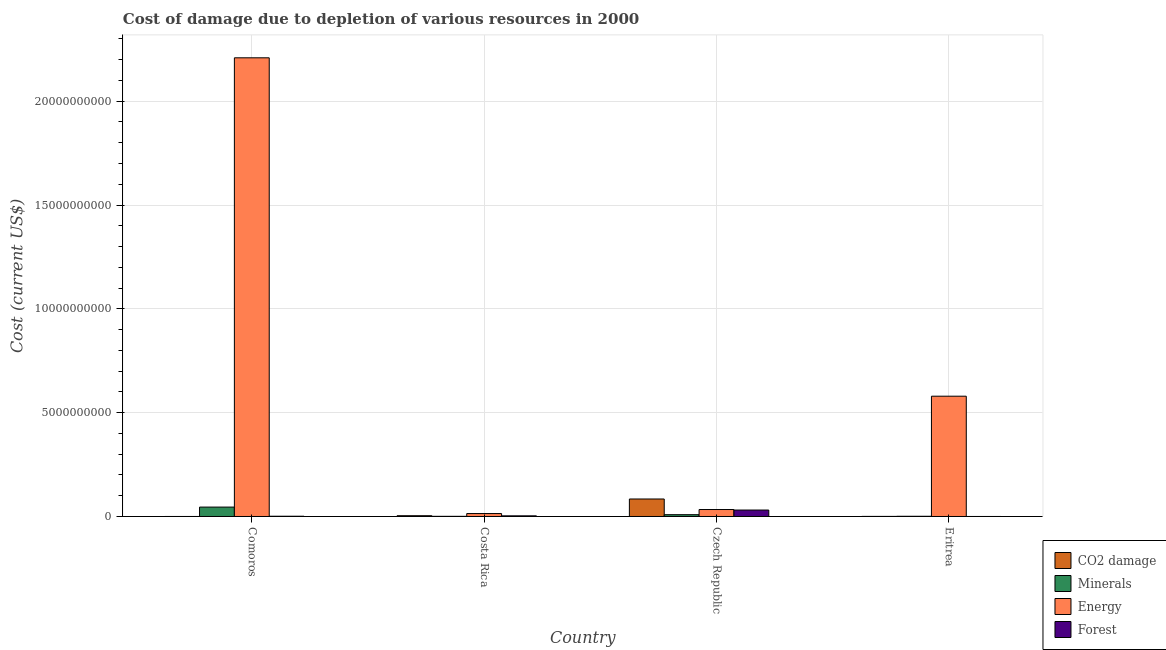Are the number of bars on each tick of the X-axis equal?
Your answer should be very brief. Yes. How many bars are there on the 3rd tick from the left?
Offer a very short reply. 4. What is the label of the 1st group of bars from the left?
Keep it short and to the point. Comoros. What is the cost of damage due to depletion of coal in Czech Republic?
Ensure brevity in your answer.  8.42e+08. Across all countries, what is the maximum cost of damage due to depletion of minerals?
Offer a very short reply. 4.53e+08. Across all countries, what is the minimum cost of damage due to depletion of energy?
Give a very brief answer. 1.41e+08. In which country was the cost of damage due to depletion of energy maximum?
Keep it short and to the point. Comoros. In which country was the cost of damage due to depletion of coal minimum?
Offer a very short reply. Comoros. What is the total cost of damage due to depletion of forests in the graph?
Ensure brevity in your answer.  3.54e+08. What is the difference between the cost of damage due to depletion of forests in Comoros and that in Czech Republic?
Make the answer very short. -2.98e+08. What is the difference between the cost of damage due to depletion of energy in Comoros and the cost of damage due to depletion of coal in Eritrea?
Give a very brief answer. 2.21e+1. What is the average cost of damage due to depletion of coal per country?
Give a very brief answer. 2.21e+08. What is the difference between the cost of damage due to depletion of energy and cost of damage due to depletion of forests in Czech Republic?
Offer a very short reply. 2.53e+07. What is the ratio of the cost of damage due to depletion of forests in Costa Rica to that in Eritrea?
Your answer should be compact. 665.52. Is the cost of damage due to depletion of energy in Costa Rica less than that in Czech Republic?
Provide a succinct answer. Yes. What is the difference between the highest and the second highest cost of damage due to depletion of minerals?
Give a very brief answer. 3.66e+08. What is the difference between the highest and the lowest cost of damage due to depletion of forests?
Keep it short and to the point. 3.10e+08. In how many countries, is the cost of damage due to depletion of minerals greater than the average cost of damage due to depletion of minerals taken over all countries?
Offer a terse response. 1. Is the sum of the cost of damage due to depletion of energy in Comoros and Czech Republic greater than the maximum cost of damage due to depletion of coal across all countries?
Make the answer very short. Yes. What does the 2nd bar from the left in Czech Republic represents?
Ensure brevity in your answer.  Minerals. What does the 3rd bar from the right in Czech Republic represents?
Ensure brevity in your answer.  Minerals. Is it the case that in every country, the sum of the cost of damage due to depletion of coal and cost of damage due to depletion of minerals is greater than the cost of damage due to depletion of energy?
Provide a succinct answer. No. What is the difference between two consecutive major ticks on the Y-axis?
Your answer should be very brief. 5.00e+09. Are the values on the major ticks of Y-axis written in scientific E-notation?
Provide a short and direct response. No. Where does the legend appear in the graph?
Give a very brief answer. Bottom right. How many legend labels are there?
Your response must be concise. 4. What is the title of the graph?
Make the answer very short. Cost of damage due to depletion of various resources in 2000 . Does "Rule based governance" appear as one of the legend labels in the graph?
Your response must be concise. No. What is the label or title of the Y-axis?
Ensure brevity in your answer.  Cost (current US$). What is the Cost (current US$) of CO2 damage in Comoros?
Offer a very short reply. 5.74e+05. What is the Cost (current US$) of Minerals in Comoros?
Ensure brevity in your answer.  4.53e+08. What is the Cost (current US$) in Energy in Comoros?
Offer a very short reply. 2.21e+1. What is the Cost (current US$) in Forest in Comoros?
Keep it short and to the point. 1.21e+07. What is the Cost (current US$) in CO2 damage in Costa Rica?
Offer a terse response. 3.73e+07. What is the Cost (current US$) of Minerals in Costa Rica?
Your answer should be compact. 7.79e+06. What is the Cost (current US$) in Energy in Costa Rica?
Ensure brevity in your answer.  1.41e+08. What is the Cost (current US$) of Forest in Costa Rica?
Provide a short and direct response. 3.11e+07. What is the Cost (current US$) in CO2 damage in Czech Republic?
Give a very brief answer. 8.42e+08. What is the Cost (current US$) in Minerals in Czech Republic?
Offer a very short reply. 8.69e+07. What is the Cost (current US$) of Energy in Czech Republic?
Ensure brevity in your answer.  3.36e+08. What is the Cost (current US$) in Forest in Czech Republic?
Make the answer very short. 3.10e+08. What is the Cost (current US$) in CO2 damage in Eritrea?
Your answer should be compact. 4.15e+06. What is the Cost (current US$) in Minerals in Eritrea?
Give a very brief answer. 1.04e+07. What is the Cost (current US$) of Energy in Eritrea?
Ensure brevity in your answer.  5.79e+09. What is the Cost (current US$) of Forest in Eritrea?
Give a very brief answer. 4.68e+04. Across all countries, what is the maximum Cost (current US$) of CO2 damage?
Ensure brevity in your answer.  8.42e+08. Across all countries, what is the maximum Cost (current US$) in Minerals?
Make the answer very short. 4.53e+08. Across all countries, what is the maximum Cost (current US$) in Energy?
Provide a short and direct response. 2.21e+1. Across all countries, what is the maximum Cost (current US$) in Forest?
Offer a terse response. 3.10e+08. Across all countries, what is the minimum Cost (current US$) of CO2 damage?
Provide a short and direct response. 5.74e+05. Across all countries, what is the minimum Cost (current US$) in Minerals?
Your response must be concise. 7.79e+06. Across all countries, what is the minimum Cost (current US$) in Energy?
Keep it short and to the point. 1.41e+08. Across all countries, what is the minimum Cost (current US$) in Forest?
Offer a terse response. 4.68e+04. What is the total Cost (current US$) in CO2 damage in the graph?
Make the answer very short. 8.84e+08. What is the total Cost (current US$) in Minerals in the graph?
Make the answer very short. 5.58e+08. What is the total Cost (current US$) in Energy in the graph?
Keep it short and to the point. 2.84e+1. What is the total Cost (current US$) of Forest in the graph?
Ensure brevity in your answer.  3.54e+08. What is the difference between the Cost (current US$) in CO2 damage in Comoros and that in Costa Rica?
Provide a succinct answer. -3.67e+07. What is the difference between the Cost (current US$) in Minerals in Comoros and that in Costa Rica?
Your answer should be compact. 4.45e+08. What is the difference between the Cost (current US$) of Energy in Comoros and that in Costa Rica?
Make the answer very short. 2.19e+1. What is the difference between the Cost (current US$) of Forest in Comoros and that in Costa Rica?
Offer a terse response. -1.90e+07. What is the difference between the Cost (current US$) in CO2 damage in Comoros and that in Czech Republic?
Keep it short and to the point. -8.42e+08. What is the difference between the Cost (current US$) of Minerals in Comoros and that in Czech Republic?
Offer a terse response. 3.66e+08. What is the difference between the Cost (current US$) in Energy in Comoros and that in Czech Republic?
Provide a succinct answer. 2.18e+1. What is the difference between the Cost (current US$) of Forest in Comoros and that in Czech Republic?
Your answer should be very brief. -2.98e+08. What is the difference between the Cost (current US$) of CO2 damage in Comoros and that in Eritrea?
Ensure brevity in your answer.  -3.57e+06. What is the difference between the Cost (current US$) of Minerals in Comoros and that in Eritrea?
Ensure brevity in your answer.  4.42e+08. What is the difference between the Cost (current US$) in Energy in Comoros and that in Eritrea?
Give a very brief answer. 1.63e+1. What is the difference between the Cost (current US$) in Forest in Comoros and that in Eritrea?
Make the answer very short. 1.21e+07. What is the difference between the Cost (current US$) of CO2 damage in Costa Rica and that in Czech Republic?
Offer a very short reply. -8.05e+08. What is the difference between the Cost (current US$) in Minerals in Costa Rica and that in Czech Republic?
Make the answer very short. -7.91e+07. What is the difference between the Cost (current US$) in Energy in Costa Rica and that in Czech Republic?
Offer a very short reply. -1.95e+08. What is the difference between the Cost (current US$) of Forest in Costa Rica and that in Czech Republic?
Offer a very short reply. -2.79e+08. What is the difference between the Cost (current US$) of CO2 damage in Costa Rica and that in Eritrea?
Offer a terse response. 3.31e+07. What is the difference between the Cost (current US$) in Minerals in Costa Rica and that in Eritrea?
Give a very brief answer. -2.63e+06. What is the difference between the Cost (current US$) in Energy in Costa Rica and that in Eritrea?
Provide a short and direct response. -5.65e+09. What is the difference between the Cost (current US$) of Forest in Costa Rica and that in Eritrea?
Provide a short and direct response. 3.11e+07. What is the difference between the Cost (current US$) in CO2 damage in Czech Republic and that in Eritrea?
Offer a very short reply. 8.38e+08. What is the difference between the Cost (current US$) in Minerals in Czech Republic and that in Eritrea?
Offer a terse response. 7.64e+07. What is the difference between the Cost (current US$) in Energy in Czech Republic and that in Eritrea?
Make the answer very short. -5.46e+09. What is the difference between the Cost (current US$) in Forest in Czech Republic and that in Eritrea?
Offer a very short reply. 3.10e+08. What is the difference between the Cost (current US$) of CO2 damage in Comoros and the Cost (current US$) of Minerals in Costa Rica?
Offer a very short reply. -7.22e+06. What is the difference between the Cost (current US$) in CO2 damage in Comoros and the Cost (current US$) in Energy in Costa Rica?
Give a very brief answer. -1.40e+08. What is the difference between the Cost (current US$) of CO2 damage in Comoros and the Cost (current US$) of Forest in Costa Rica?
Provide a short and direct response. -3.05e+07. What is the difference between the Cost (current US$) of Minerals in Comoros and the Cost (current US$) of Energy in Costa Rica?
Provide a short and direct response. 3.12e+08. What is the difference between the Cost (current US$) of Minerals in Comoros and the Cost (current US$) of Forest in Costa Rica?
Offer a terse response. 4.22e+08. What is the difference between the Cost (current US$) of Energy in Comoros and the Cost (current US$) of Forest in Costa Rica?
Ensure brevity in your answer.  2.21e+1. What is the difference between the Cost (current US$) of CO2 damage in Comoros and the Cost (current US$) of Minerals in Czech Republic?
Your answer should be compact. -8.63e+07. What is the difference between the Cost (current US$) in CO2 damage in Comoros and the Cost (current US$) in Energy in Czech Republic?
Provide a short and direct response. -3.35e+08. What is the difference between the Cost (current US$) in CO2 damage in Comoros and the Cost (current US$) in Forest in Czech Republic?
Your response must be concise. -3.10e+08. What is the difference between the Cost (current US$) in Minerals in Comoros and the Cost (current US$) in Energy in Czech Republic?
Your answer should be very brief. 1.17e+08. What is the difference between the Cost (current US$) of Minerals in Comoros and the Cost (current US$) of Forest in Czech Republic?
Give a very brief answer. 1.42e+08. What is the difference between the Cost (current US$) of Energy in Comoros and the Cost (current US$) of Forest in Czech Republic?
Ensure brevity in your answer.  2.18e+1. What is the difference between the Cost (current US$) of CO2 damage in Comoros and the Cost (current US$) of Minerals in Eritrea?
Your response must be concise. -9.85e+06. What is the difference between the Cost (current US$) of CO2 damage in Comoros and the Cost (current US$) of Energy in Eritrea?
Provide a succinct answer. -5.79e+09. What is the difference between the Cost (current US$) in CO2 damage in Comoros and the Cost (current US$) in Forest in Eritrea?
Your answer should be very brief. 5.28e+05. What is the difference between the Cost (current US$) in Minerals in Comoros and the Cost (current US$) in Energy in Eritrea?
Provide a short and direct response. -5.34e+09. What is the difference between the Cost (current US$) in Minerals in Comoros and the Cost (current US$) in Forest in Eritrea?
Your answer should be very brief. 4.53e+08. What is the difference between the Cost (current US$) in Energy in Comoros and the Cost (current US$) in Forest in Eritrea?
Provide a succinct answer. 2.21e+1. What is the difference between the Cost (current US$) in CO2 damage in Costa Rica and the Cost (current US$) in Minerals in Czech Republic?
Offer a terse response. -4.96e+07. What is the difference between the Cost (current US$) of CO2 damage in Costa Rica and the Cost (current US$) of Energy in Czech Republic?
Your answer should be very brief. -2.98e+08. What is the difference between the Cost (current US$) in CO2 damage in Costa Rica and the Cost (current US$) in Forest in Czech Republic?
Make the answer very short. -2.73e+08. What is the difference between the Cost (current US$) of Minerals in Costa Rica and the Cost (current US$) of Energy in Czech Republic?
Keep it short and to the point. -3.28e+08. What is the difference between the Cost (current US$) in Minerals in Costa Rica and the Cost (current US$) in Forest in Czech Republic?
Give a very brief answer. -3.03e+08. What is the difference between the Cost (current US$) in Energy in Costa Rica and the Cost (current US$) in Forest in Czech Republic?
Your answer should be very brief. -1.70e+08. What is the difference between the Cost (current US$) of CO2 damage in Costa Rica and the Cost (current US$) of Minerals in Eritrea?
Offer a terse response. 2.69e+07. What is the difference between the Cost (current US$) of CO2 damage in Costa Rica and the Cost (current US$) of Energy in Eritrea?
Your answer should be very brief. -5.76e+09. What is the difference between the Cost (current US$) in CO2 damage in Costa Rica and the Cost (current US$) in Forest in Eritrea?
Keep it short and to the point. 3.72e+07. What is the difference between the Cost (current US$) of Minerals in Costa Rica and the Cost (current US$) of Energy in Eritrea?
Your response must be concise. -5.79e+09. What is the difference between the Cost (current US$) of Minerals in Costa Rica and the Cost (current US$) of Forest in Eritrea?
Provide a succinct answer. 7.75e+06. What is the difference between the Cost (current US$) of Energy in Costa Rica and the Cost (current US$) of Forest in Eritrea?
Offer a very short reply. 1.41e+08. What is the difference between the Cost (current US$) of CO2 damage in Czech Republic and the Cost (current US$) of Minerals in Eritrea?
Offer a terse response. 8.32e+08. What is the difference between the Cost (current US$) of CO2 damage in Czech Republic and the Cost (current US$) of Energy in Eritrea?
Ensure brevity in your answer.  -4.95e+09. What is the difference between the Cost (current US$) in CO2 damage in Czech Republic and the Cost (current US$) in Forest in Eritrea?
Provide a short and direct response. 8.42e+08. What is the difference between the Cost (current US$) in Minerals in Czech Republic and the Cost (current US$) in Energy in Eritrea?
Give a very brief answer. -5.71e+09. What is the difference between the Cost (current US$) of Minerals in Czech Republic and the Cost (current US$) of Forest in Eritrea?
Make the answer very short. 8.68e+07. What is the difference between the Cost (current US$) of Energy in Czech Republic and the Cost (current US$) of Forest in Eritrea?
Offer a very short reply. 3.36e+08. What is the average Cost (current US$) of CO2 damage per country?
Give a very brief answer. 2.21e+08. What is the average Cost (current US$) in Minerals per country?
Your answer should be very brief. 1.39e+08. What is the average Cost (current US$) in Energy per country?
Your answer should be compact. 7.09e+09. What is the average Cost (current US$) of Forest per country?
Give a very brief answer. 8.84e+07. What is the difference between the Cost (current US$) of CO2 damage and Cost (current US$) of Minerals in Comoros?
Ensure brevity in your answer.  -4.52e+08. What is the difference between the Cost (current US$) in CO2 damage and Cost (current US$) in Energy in Comoros?
Your answer should be compact. -2.21e+1. What is the difference between the Cost (current US$) in CO2 damage and Cost (current US$) in Forest in Comoros?
Provide a succinct answer. -1.16e+07. What is the difference between the Cost (current US$) in Minerals and Cost (current US$) in Energy in Comoros?
Your answer should be compact. -2.16e+1. What is the difference between the Cost (current US$) of Minerals and Cost (current US$) of Forest in Comoros?
Your answer should be compact. 4.41e+08. What is the difference between the Cost (current US$) of Energy and Cost (current US$) of Forest in Comoros?
Your answer should be compact. 2.21e+1. What is the difference between the Cost (current US$) in CO2 damage and Cost (current US$) in Minerals in Costa Rica?
Ensure brevity in your answer.  2.95e+07. What is the difference between the Cost (current US$) in CO2 damage and Cost (current US$) in Energy in Costa Rica?
Ensure brevity in your answer.  -1.04e+08. What is the difference between the Cost (current US$) of CO2 damage and Cost (current US$) of Forest in Costa Rica?
Keep it short and to the point. 6.17e+06. What is the difference between the Cost (current US$) in Minerals and Cost (current US$) in Energy in Costa Rica?
Make the answer very short. -1.33e+08. What is the difference between the Cost (current US$) in Minerals and Cost (current US$) in Forest in Costa Rica?
Give a very brief answer. -2.33e+07. What is the difference between the Cost (current US$) of Energy and Cost (current US$) of Forest in Costa Rica?
Provide a short and direct response. 1.10e+08. What is the difference between the Cost (current US$) in CO2 damage and Cost (current US$) in Minerals in Czech Republic?
Your response must be concise. 7.56e+08. What is the difference between the Cost (current US$) in CO2 damage and Cost (current US$) in Energy in Czech Republic?
Your answer should be compact. 5.07e+08. What is the difference between the Cost (current US$) of CO2 damage and Cost (current US$) of Forest in Czech Republic?
Offer a terse response. 5.32e+08. What is the difference between the Cost (current US$) in Minerals and Cost (current US$) in Energy in Czech Republic?
Your answer should be very brief. -2.49e+08. What is the difference between the Cost (current US$) of Minerals and Cost (current US$) of Forest in Czech Republic?
Your response must be concise. -2.24e+08. What is the difference between the Cost (current US$) of Energy and Cost (current US$) of Forest in Czech Republic?
Provide a succinct answer. 2.53e+07. What is the difference between the Cost (current US$) of CO2 damage and Cost (current US$) of Minerals in Eritrea?
Your answer should be compact. -6.28e+06. What is the difference between the Cost (current US$) in CO2 damage and Cost (current US$) in Energy in Eritrea?
Ensure brevity in your answer.  -5.79e+09. What is the difference between the Cost (current US$) of CO2 damage and Cost (current US$) of Forest in Eritrea?
Make the answer very short. 4.10e+06. What is the difference between the Cost (current US$) in Minerals and Cost (current US$) in Energy in Eritrea?
Offer a very short reply. -5.78e+09. What is the difference between the Cost (current US$) of Minerals and Cost (current US$) of Forest in Eritrea?
Make the answer very short. 1.04e+07. What is the difference between the Cost (current US$) in Energy and Cost (current US$) in Forest in Eritrea?
Provide a short and direct response. 5.79e+09. What is the ratio of the Cost (current US$) in CO2 damage in Comoros to that in Costa Rica?
Offer a terse response. 0.02. What is the ratio of the Cost (current US$) of Minerals in Comoros to that in Costa Rica?
Give a very brief answer. 58.09. What is the ratio of the Cost (current US$) of Energy in Comoros to that in Costa Rica?
Keep it short and to the point. 156.89. What is the ratio of the Cost (current US$) of Forest in Comoros to that in Costa Rica?
Offer a very short reply. 0.39. What is the ratio of the Cost (current US$) in CO2 damage in Comoros to that in Czech Republic?
Offer a terse response. 0. What is the ratio of the Cost (current US$) in Minerals in Comoros to that in Czech Republic?
Your response must be concise. 5.21. What is the ratio of the Cost (current US$) of Energy in Comoros to that in Czech Republic?
Provide a short and direct response. 65.81. What is the ratio of the Cost (current US$) of Forest in Comoros to that in Czech Republic?
Your answer should be compact. 0.04. What is the ratio of the Cost (current US$) in CO2 damage in Comoros to that in Eritrea?
Provide a short and direct response. 0.14. What is the ratio of the Cost (current US$) of Minerals in Comoros to that in Eritrea?
Your answer should be compact. 43.42. What is the ratio of the Cost (current US$) in Energy in Comoros to that in Eritrea?
Give a very brief answer. 3.81. What is the ratio of the Cost (current US$) in Forest in Comoros to that in Eritrea?
Offer a very short reply. 259.7. What is the ratio of the Cost (current US$) of CO2 damage in Costa Rica to that in Czech Republic?
Your response must be concise. 0.04. What is the ratio of the Cost (current US$) in Minerals in Costa Rica to that in Czech Republic?
Provide a succinct answer. 0.09. What is the ratio of the Cost (current US$) in Energy in Costa Rica to that in Czech Republic?
Offer a very short reply. 0.42. What is the ratio of the Cost (current US$) of Forest in Costa Rica to that in Czech Republic?
Your answer should be compact. 0.1. What is the ratio of the Cost (current US$) of CO2 damage in Costa Rica to that in Eritrea?
Offer a very short reply. 8.99. What is the ratio of the Cost (current US$) of Minerals in Costa Rica to that in Eritrea?
Offer a very short reply. 0.75. What is the ratio of the Cost (current US$) in Energy in Costa Rica to that in Eritrea?
Make the answer very short. 0.02. What is the ratio of the Cost (current US$) of Forest in Costa Rica to that in Eritrea?
Your answer should be very brief. 665.52. What is the ratio of the Cost (current US$) in CO2 damage in Czech Republic to that in Eritrea?
Give a very brief answer. 203.19. What is the ratio of the Cost (current US$) in Minerals in Czech Republic to that in Eritrea?
Make the answer very short. 8.33. What is the ratio of the Cost (current US$) in Energy in Czech Republic to that in Eritrea?
Your response must be concise. 0.06. What is the ratio of the Cost (current US$) in Forest in Czech Republic to that in Eritrea?
Offer a terse response. 6637.14. What is the difference between the highest and the second highest Cost (current US$) in CO2 damage?
Your answer should be compact. 8.05e+08. What is the difference between the highest and the second highest Cost (current US$) in Minerals?
Keep it short and to the point. 3.66e+08. What is the difference between the highest and the second highest Cost (current US$) of Energy?
Your answer should be compact. 1.63e+1. What is the difference between the highest and the second highest Cost (current US$) of Forest?
Keep it short and to the point. 2.79e+08. What is the difference between the highest and the lowest Cost (current US$) of CO2 damage?
Your response must be concise. 8.42e+08. What is the difference between the highest and the lowest Cost (current US$) in Minerals?
Your answer should be compact. 4.45e+08. What is the difference between the highest and the lowest Cost (current US$) of Energy?
Keep it short and to the point. 2.19e+1. What is the difference between the highest and the lowest Cost (current US$) in Forest?
Offer a terse response. 3.10e+08. 